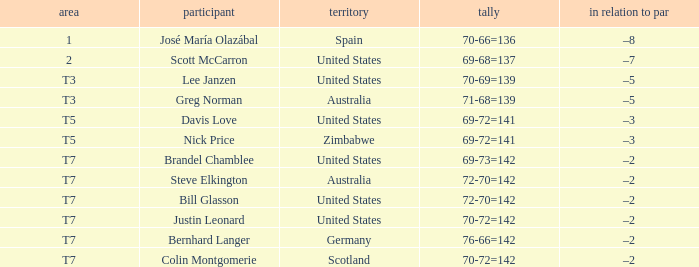WHich Score has a To par of –3, and a Country of united states? 69-72=141. 